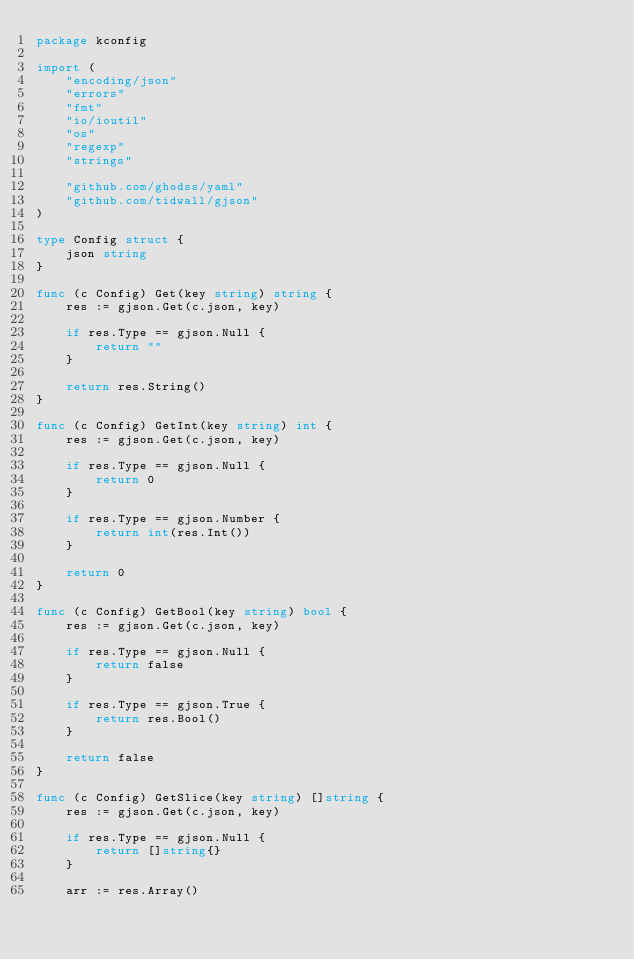<code> <loc_0><loc_0><loc_500><loc_500><_Go_>package kconfig

import (
	"encoding/json"
	"errors"
	"fmt"
	"io/ioutil"
	"os"
	"regexp"
	"strings"

	"github.com/ghodss/yaml"
	"github.com/tidwall/gjson"
)

type Config struct {
	json string
}

func (c Config) Get(key string) string {
	res := gjson.Get(c.json, key)

	if res.Type == gjson.Null {
		return ""
	}

	return res.String()
}

func (c Config) GetInt(key string) int {
	res := gjson.Get(c.json, key)

	if res.Type == gjson.Null {
		return 0
	}

	if res.Type == gjson.Number {
		return int(res.Int())
	}

	return 0
}

func (c Config) GetBool(key string) bool {
	res := gjson.Get(c.json, key)

	if res.Type == gjson.Null {
		return false
	}

	if res.Type == gjson.True {
		return res.Bool()
	}

	return false
}

func (c Config) GetSlice(key string) []string {
	res := gjson.Get(c.json, key)

	if res.Type == gjson.Null {
		return []string{}
	}

	arr := res.Array()</code> 